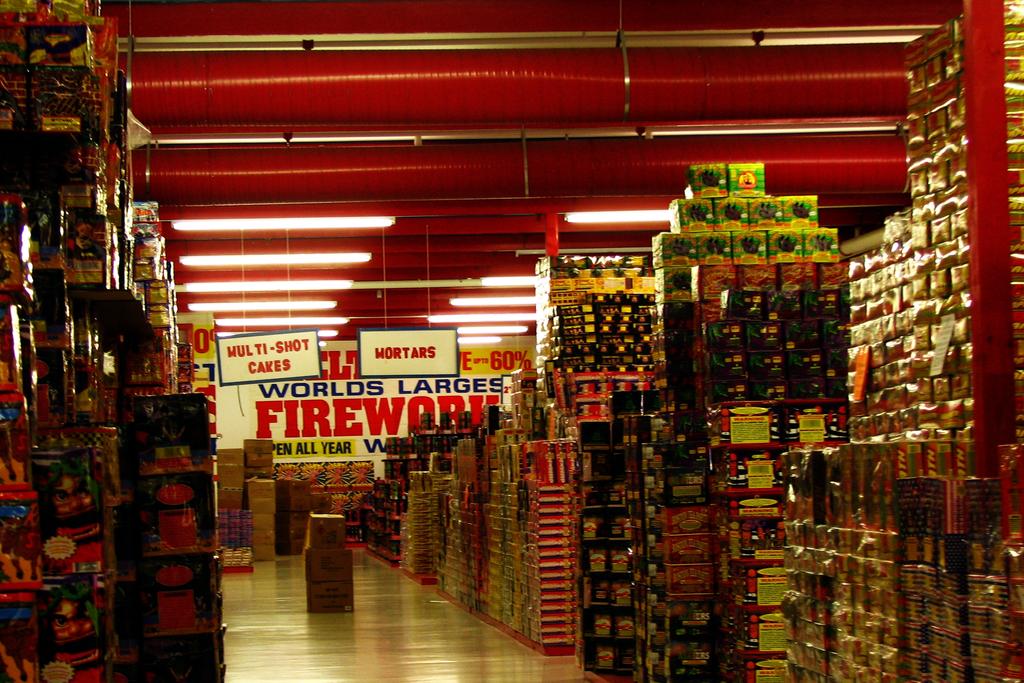What types of this store?
Your answer should be compact. Fireworks. What is being sold in this store?
Offer a very short reply. Fireworks. 